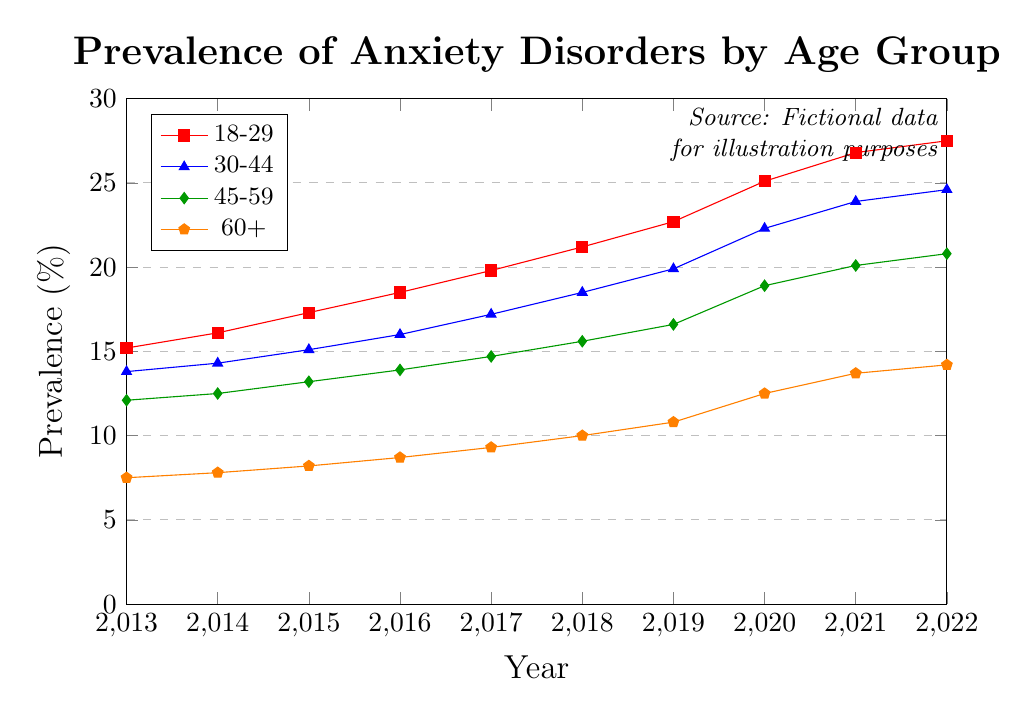What's the trend in the prevalence of anxiety disorders for the 18-29 age group over the past decade? The prevalence of anxiety disorders in the 18-29 age group shows a clear upward trend. Starting from 15.2% in 2013, it increased steadily every year, reaching 27.5% in 2022.
Answer: Upward trend Which age group had the highest prevalence of anxiety disorders in 2020? By visually inspecting the year 2020 on the x-axis and checking the values across different age groups, it's clear that the 18-29 age group had the highest prevalence with 25.1%.
Answer: 18-29 How does the prevalence of anxiety disorders in 2022 compare between the 45-59 and 60+ age groups? In 2022, the prevalence in the 45-59 age group is 20.8%, while in the 60+ age group it is 14.2%. Comparing these values, the 45-59 age group has a higher prevalence.
Answer: 45-59 is higher What is the rate of increase in the prevalence of anxiety disorders from 2013 to 2022 for the 30-44 age group? The prevalence in 2013 was 13.8%, and it rose to 24.6% in 2022. The increase is calculated as 24.6% - 13.8% = 10.8%.
Answer: 10.8% What is the average prevalence of anxiety disorders for the 60+ age group over the given period? To find the average, sum all prevalence values for the 60+ age group from 2013 to 2022 and divide by the number of years. The total is (7.5 + 7.8 + 8.2 + 8.7 + 9.3 + 10.0 + 10.8 + 12.5 + 13.7 + 14.2) = 103.7. Then, 103.7 divided by 10 is 10.37.
Answer: 10.37% In which year did the prevalence of anxiety disorders in the 18-29 age group exceed 20%? By examining the plotted values chronologically, the prevalence in the 18-29 age group first exceeded 20% in the year 2018.
Answer: 2018 Between which years did the prevalence of anxiety disorders in the 60+ age group show the highest annual increase? Comparing the year-over-year changes, the highest increase is between 2019 (10.8%) and 2020 (12.5%), which is an increase of 1.7%.
Answer: 2019 and 2020 What is the difference in the prevalence of anxiety disorders between the age group 30-44 and 45-59 in the year 2015? In 2015, the prevalence for the 30-44 age group was 15.1% and for the 45-59 age group it was 13.2%. The difference is 15.1% - 13.2% = 1.9%.
Answer: 1.9% What year did the 45-59 age group see a prevalence of 20% or more for the first time? By scanning the data points for the 45-59 age group, the prevalence first reaches 20% in the year 2021, where it is 20.1%.
Answer: 2021 